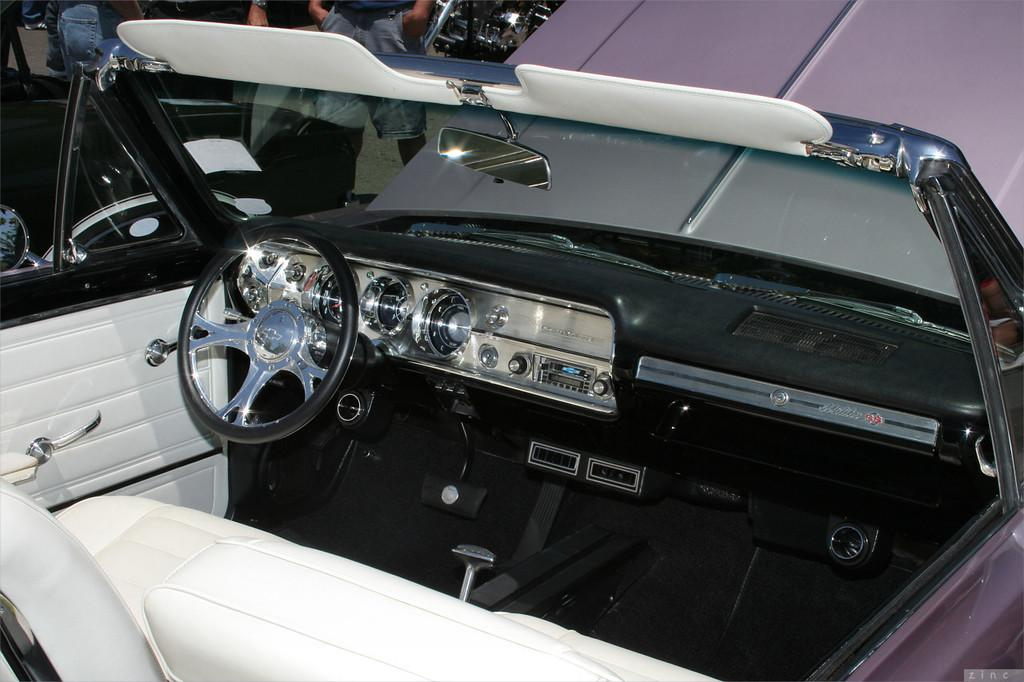What type of setting is shown in the image? The image depicts the interior of a car. What type of suit can be seen hanging in the car? There is no suit visible in the image, as it depicts the interior of a car and not a clothing item. 